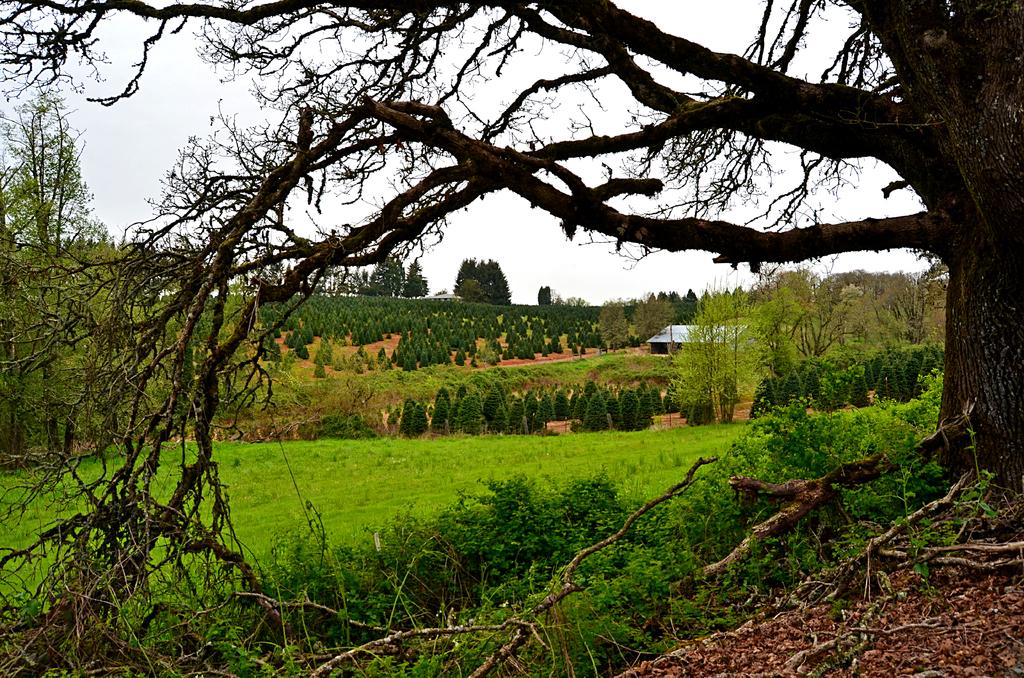What type of vegetation can be seen in the image? There is a tree and plants near the tree in the image. What is the surface beneath the tree and plants? There is a grass surface in the image. What can be seen in the background of the image? There are trees and the sky visible in the background of the image. How many screws can be seen holding the tree to the ground in the image? There are no screws visible in the image; the tree is not attached to the ground. Can you tell me how many birds are flying around the tree in the image? There are no birds visible in the image; only the tree, plants, grass surface, and background elements are present. 